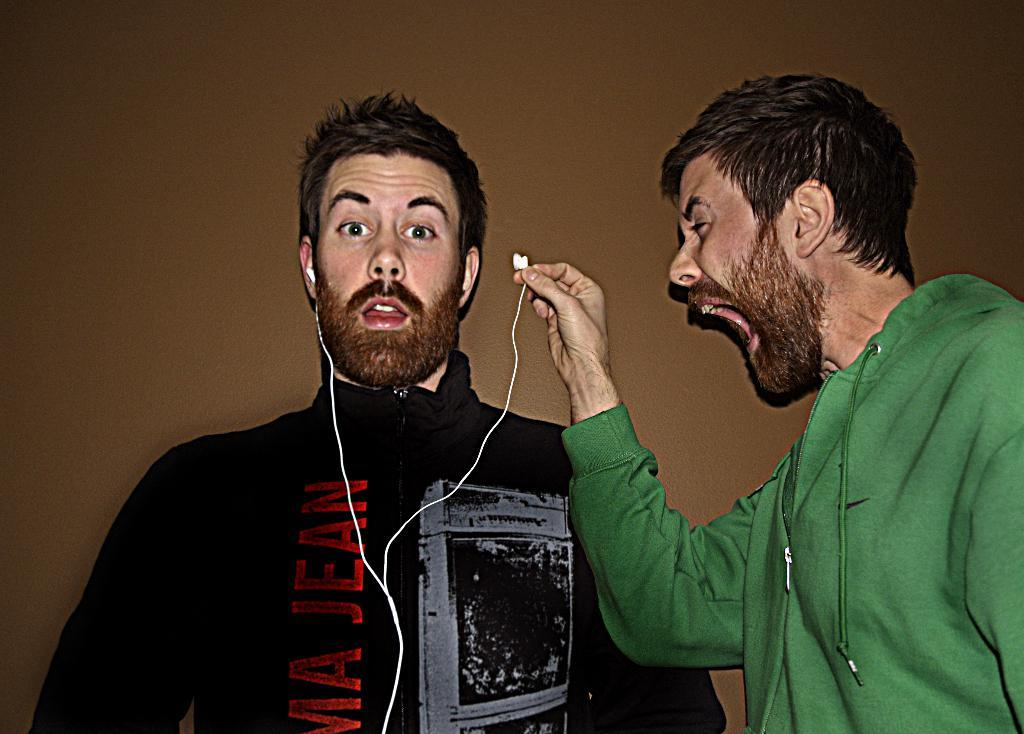How many people are present in the image? There are two people in the image. What is one of the people holding in his hand? One of the people is holding an earphone in his hand. What type of bells can be heard ringing in the image? There are no bells present in the image, and therefore no ringing can be heard. What is the person using to comb their hair in the image? There is no comb visible in the image, and the person is not shown combing their hair. 